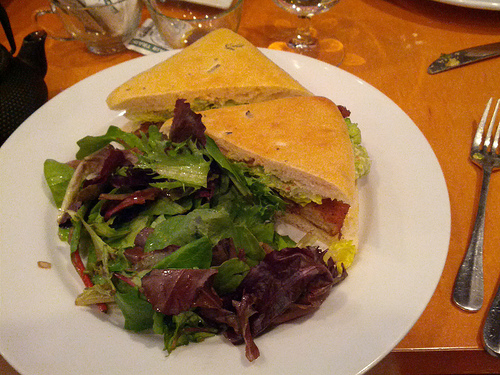Describe the salad's ingredients visible in this image. The salad consists of mixed greens, likely a blend of arugula, radicchio, and romaine, which provide a variety of textures and slightly bitter flavors, complementing the main dish. 